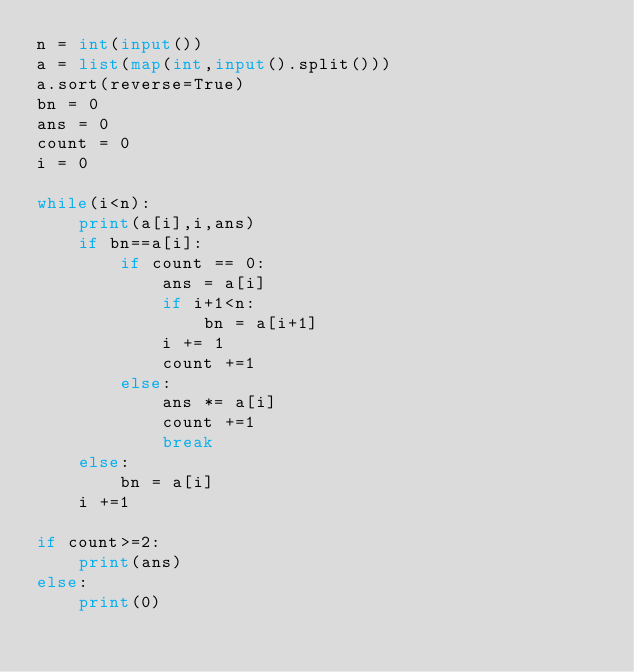Convert code to text. <code><loc_0><loc_0><loc_500><loc_500><_Python_>n = int(input())
a = list(map(int,input().split()))
a.sort(reverse=True)
bn = 0
ans = 0
count = 0
i = 0

while(i<n):
    print(a[i],i,ans)
    if bn==a[i]:
        if count == 0:
            ans = a[i]
            if i+1<n:
                bn = a[i+1]
            i += 1
            count +=1
        else:
            ans *= a[i]
            count +=1
            break
    else:
        bn = a[i]
    i +=1

if count>=2:
    print(ans)
else:
    print(0)</code> 